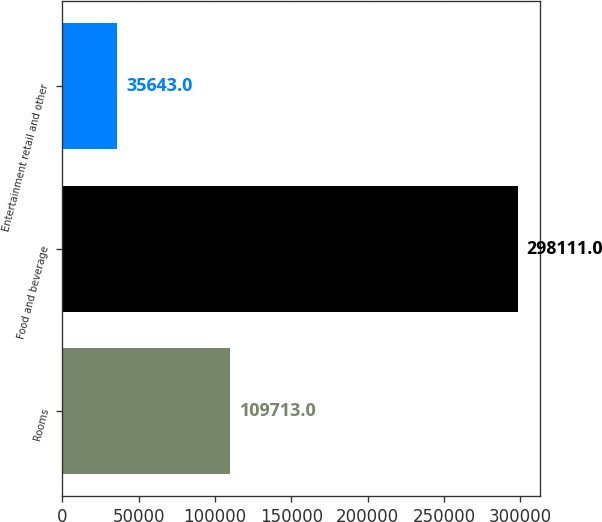<chart> <loc_0><loc_0><loc_500><loc_500><bar_chart><fcel>Rooms<fcel>Food and beverage<fcel>Entertainment retail and other<nl><fcel>109713<fcel>298111<fcel>35643<nl></chart> 